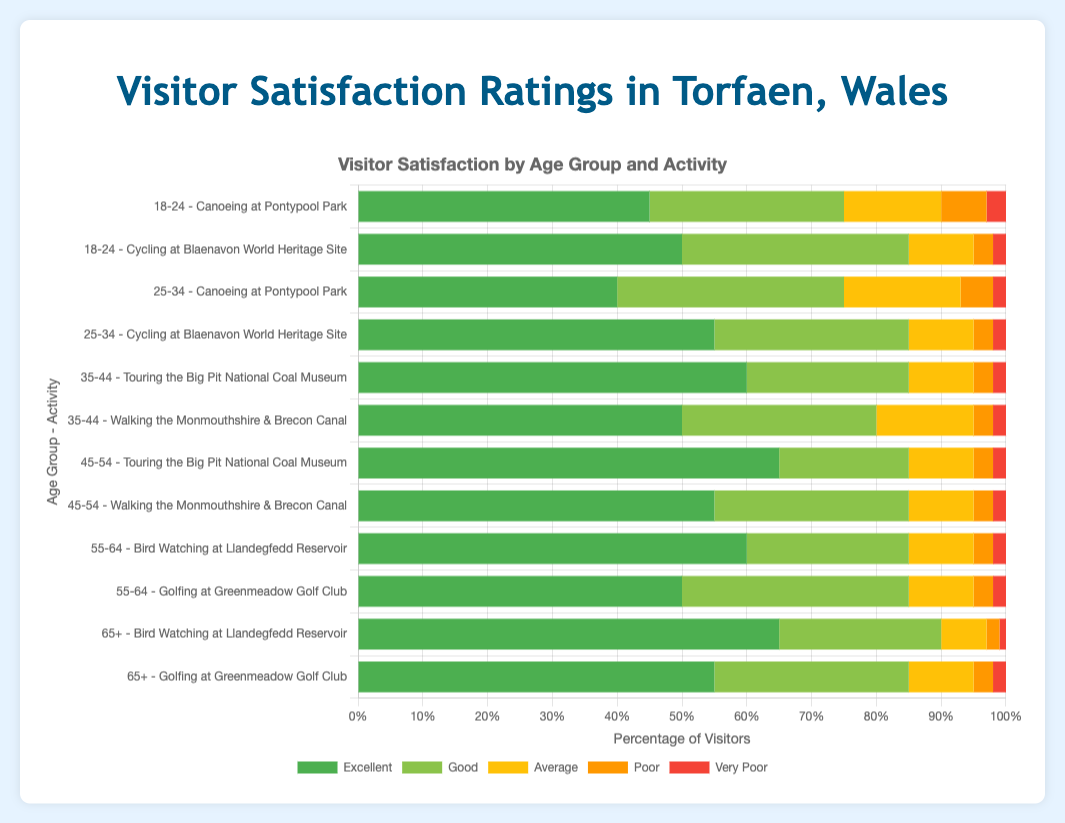Which age group rates "Canoeing at Pontypool Park" the highest in terms of "Excellent" ratings? Look at the "Canoeing at Pontypool Park" bars for different age groups and compare the "Excellent" sections. The "18-24" age group has the highest "Excellent" rating with 45%.
Answer: 18-24 What is the combined percentage of "Poor" and "Very Poor" ratings for "Cycling at Blaenavon World Heritage Site" for the 25-34 age group? Add the "Poor" percentage (3%) and "Very Poor" percentage (2%) for the 25-34 age group doing "Cycling at Blaenavon World Heritage Site". 3% + 2% = 5%
Answer: 5% Between "Touring the Big Pit National Coal Museum" and "Walking the Monmouthshire & Brecon Canal", which activity received more "Excellent" ratings from the 45-54 age group? Compare the "Excellent" ratings for both activities within the 45-54 age group. "Touring the Big Pit National Coal Museum" received 65% while "Walking" received 55%, making "Touring" the higher-rated activity.
Answer: Touring the Big Pit National Coal Museum What is the average percentage of "Good" ratings across all listed activities for the "55-64" age group? Calculate the average of the "Good" ratings for "Bird Watching at Llandegfedd Reservoir" (25%) and "Golfing at Greenmeadow Golf Club" (35%). (25% + 35%)/2 = 30%
Answer: 30% Which activity has the lowest "Very Poor" rating for the 65+ age group? The "Very Poor" sections for the 65+ age group activities are "Bird Watching at Llandegfedd Reservoir" (1%) and "Golfing at Greenmeadow Golf Club" (2%). The lowest "Very Poor" rating is for "Bird Watching at Llandegfedd Reservoir".
Answer: Bird Watching at Llandegfedd Reservoir How does the "Excellent" rating for "Walking the Monmouthshire & Brecon Canal" compare between the 35-44 and 45-54 age groups? Compare the "Excellent" bars for the mentioned activity between the two age groups. The 35-44 age group has 50% "Excellent" and the 45-54 age group has 55% "Excellent". Thus, the 45-54 group rates it 5% higher.
Answer: The 45-54 age group rates it 5% higher What is the total percentage of "Average" ratings given by the 18-24 age group for both activities listed? Sum the "Average" ratings for the 18-24 age group for both activities, "Canoeing at Pontypool Park" (15%) and "Cycling at Blaenavon World Heritage Site" (10%). 15% + 10% = 25%
Answer: 25% Which activity for the 35-44 age group has the highest "Good" rating? Look at the "Good" ratings for the activities listed for the 35-44 age group. "Walking the Monmouthshire & Brecon Canal" has a "Good" rating of 30%, compared to "Touring the Big Pit National Coal Museum" with 25%.
Answer: Walking the Monmouthshire & Brecon Canal What is the difference in "Excellent" ratings between the activities "Golfing at Greenmeadow Golf Club" and "Bird Watching at Llandegfedd Reservoir" for the 55-64 age group? Subtract the "Excellent" rating of "Golfing" (50%) from "Bird Watching" (60%) for the 55-64 age group. 60% - 50% = 10%
Answer: 10% Which age group has the largest proportion of "Poor" ratings for any activity? Find the highest "Poor" rating percentage across all age groups and activities. The highest is "18-24" for "Canoeing at Pontypool Park" with 7%.
Answer: 18-24 